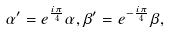<formula> <loc_0><loc_0><loc_500><loc_500>\alpha ^ { \prime } = e ^ { \frac { i \pi } 4 } \alpha , \beta ^ { \prime } = e ^ { - \frac { i \pi } 4 } \beta ,</formula> 